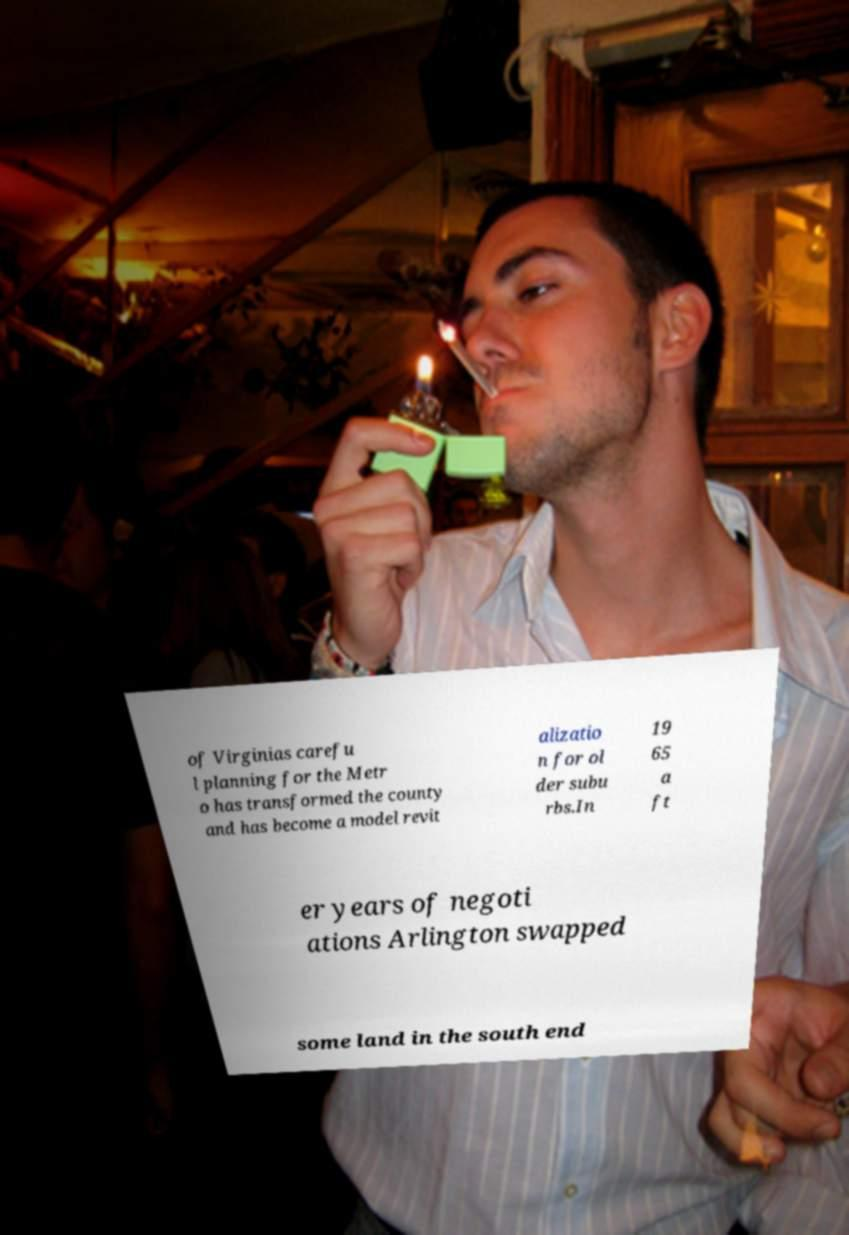Can you accurately transcribe the text from the provided image for me? of Virginias carefu l planning for the Metr o has transformed the county and has become a model revit alizatio n for ol der subu rbs.In 19 65 a ft er years of negoti ations Arlington swapped some land in the south end 